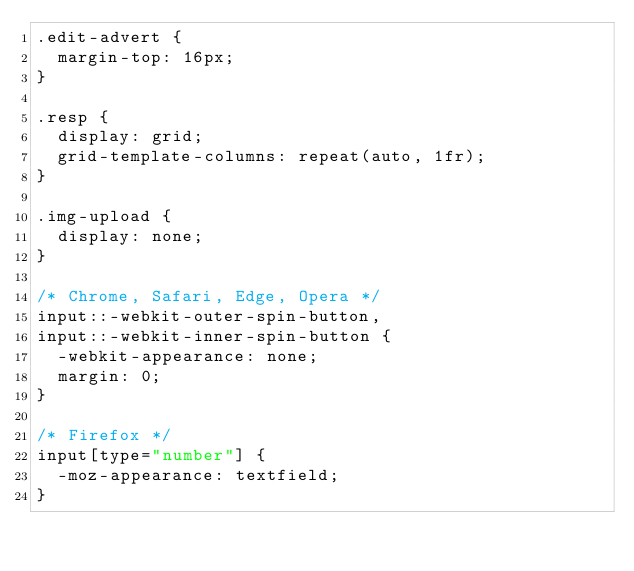<code> <loc_0><loc_0><loc_500><loc_500><_CSS_>.edit-advert {
  margin-top: 16px;
}

.resp {
  display: grid;
  grid-template-columns: repeat(auto, 1fr);
}

.img-upload {
  display: none;
}

/* Chrome, Safari, Edge, Opera */
input::-webkit-outer-spin-button,
input::-webkit-inner-spin-button {
  -webkit-appearance: none;
  margin: 0;
}

/* Firefox */
input[type="number"] {
  -moz-appearance: textfield;
}
</code> 